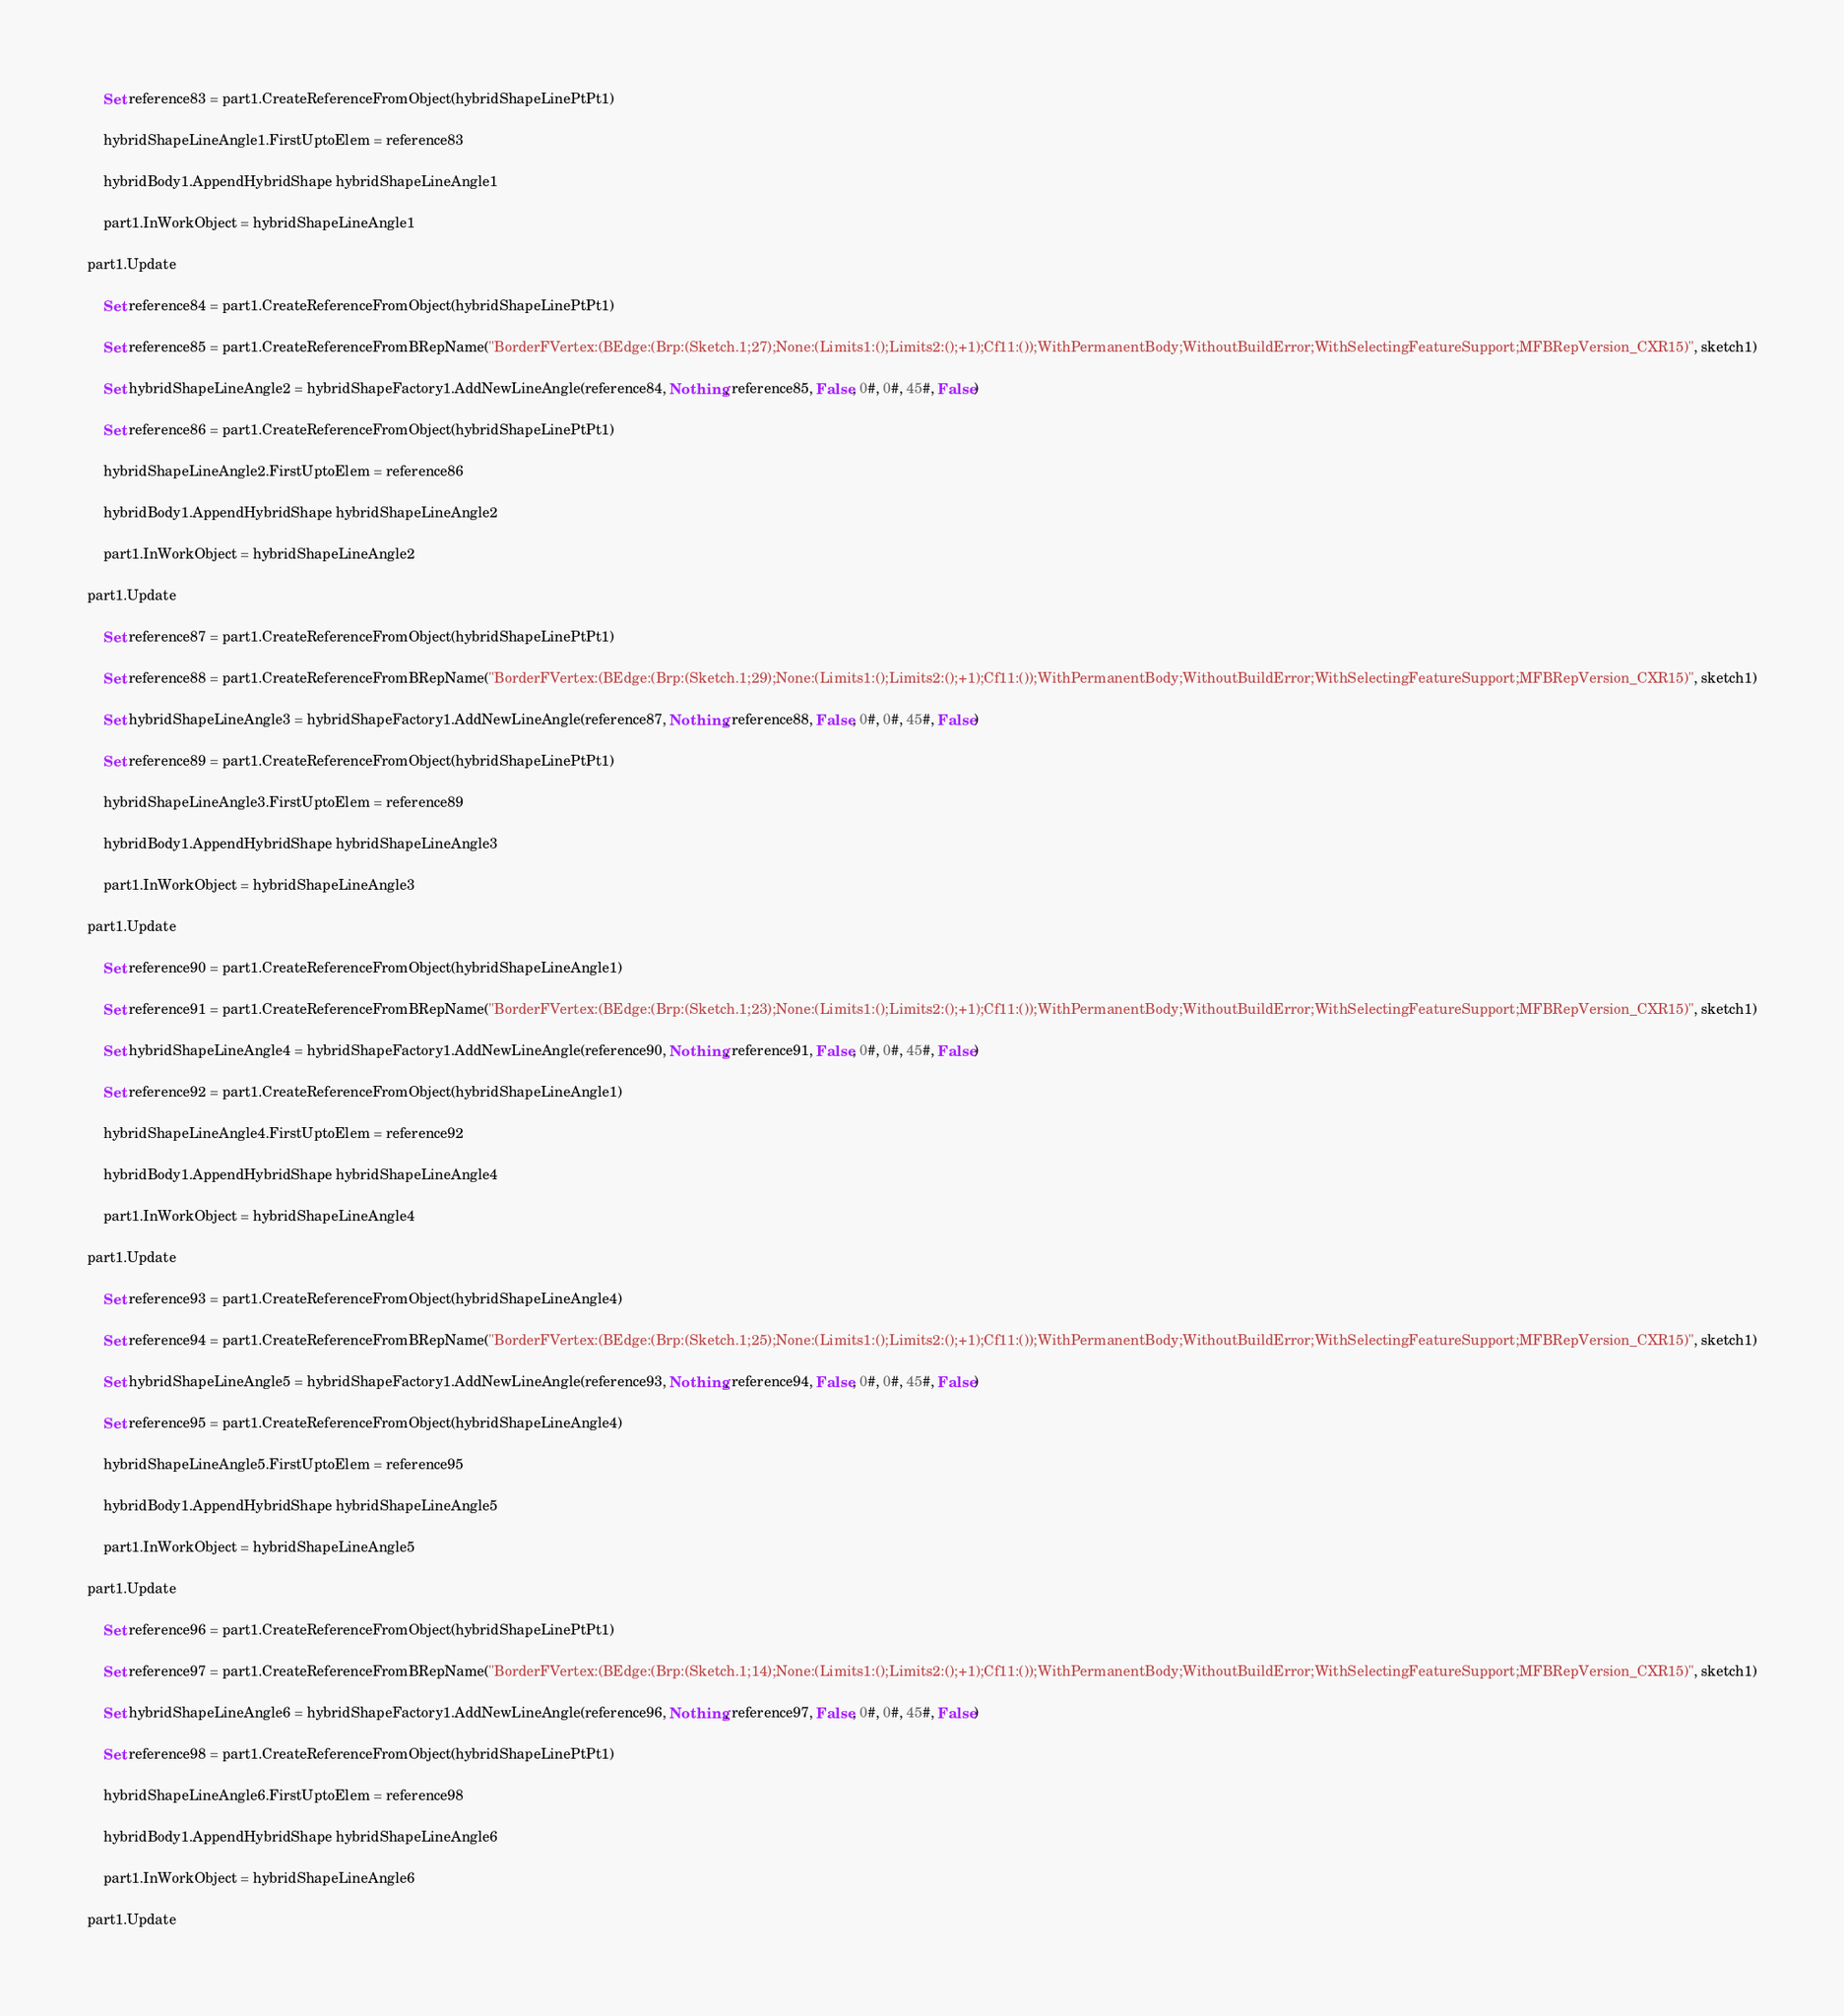Convert code to text. <code><loc_0><loc_0><loc_500><loc_500><_VisualBasic_>	Set reference83 = part1.CreateReferenceFromObject(hybridShapeLinePtPt1)

	hybridShapeLineAngle1.FirstUptoElem = reference83

	hybridBody1.AppendHybridShape hybridShapeLineAngle1

	part1.InWorkObject = hybridShapeLineAngle1

part1.Update

	Set reference84 = part1.CreateReferenceFromObject(hybridShapeLinePtPt1)

	Set reference85 = part1.CreateReferenceFromBRepName("BorderFVertex:(BEdge:(Brp:(Sketch.1;27);None:(Limits1:();Limits2:();+1);Cf11:());WithPermanentBody;WithoutBuildError;WithSelectingFeatureSupport;MFBRepVersion_CXR15)", sketch1)

	Set hybridShapeLineAngle2 = hybridShapeFactory1.AddNewLineAngle(reference84, Nothing, reference85, False, 0#, 0#, 45#, False)

	Set reference86 = part1.CreateReferenceFromObject(hybridShapeLinePtPt1)

	hybridShapeLineAngle2.FirstUptoElem = reference86

	hybridBody1.AppendHybridShape hybridShapeLineAngle2

	part1.InWorkObject = hybridShapeLineAngle2

part1.Update

	Set reference87 = part1.CreateReferenceFromObject(hybridShapeLinePtPt1)

	Set reference88 = part1.CreateReferenceFromBRepName("BorderFVertex:(BEdge:(Brp:(Sketch.1;29);None:(Limits1:();Limits2:();+1);Cf11:());WithPermanentBody;WithoutBuildError;WithSelectingFeatureSupport;MFBRepVersion_CXR15)", sketch1)

	Set hybridShapeLineAngle3 = hybridShapeFactory1.AddNewLineAngle(reference87, Nothing, reference88, False, 0#, 0#, 45#, False)

	Set reference89 = part1.CreateReferenceFromObject(hybridShapeLinePtPt1)

	hybridShapeLineAngle3.FirstUptoElem = reference89

	hybridBody1.AppendHybridShape hybridShapeLineAngle3

	part1.InWorkObject = hybridShapeLineAngle3

part1.Update

	Set reference90 = part1.CreateReferenceFromObject(hybridShapeLineAngle1)

	Set reference91 = part1.CreateReferenceFromBRepName("BorderFVertex:(BEdge:(Brp:(Sketch.1;23);None:(Limits1:();Limits2:();+1);Cf11:());WithPermanentBody;WithoutBuildError;WithSelectingFeatureSupport;MFBRepVersion_CXR15)", sketch1)

	Set hybridShapeLineAngle4 = hybridShapeFactory1.AddNewLineAngle(reference90, Nothing, reference91, False, 0#, 0#, 45#, False)

	Set reference92 = part1.CreateReferenceFromObject(hybridShapeLineAngle1)

	hybridShapeLineAngle4.FirstUptoElem = reference92

	hybridBody1.AppendHybridShape hybridShapeLineAngle4

	part1.InWorkObject = hybridShapeLineAngle4

part1.Update

	Set reference93 = part1.CreateReferenceFromObject(hybridShapeLineAngle4)

	Set reference94 = part1.CreateReferenceFromBRepName("BorderFVertex:(BEdge:(Brp:(Sketch.1;25);None:(Limits1:();Limits2:();+1);Cf11:());WithPermanentBody;WithoutBuildError;WithSelectingFeatureSupport;MFBRepVersion_CXR15)", sketch1)

	Set hybridShapeLineAngle5 = hybridShapeFactory1.AddNewLineAngle(reference93, Nothing, reference94, False, 0#, 0#, 45#, False)

	Set reference95 = part1.CreateReferenceFromObject(hybridShapeLineAngle4)

	hybridShapeLineAngle5.FirstUptoElem = reference95

	hybridBody1.AppendHybridShape hybridShapeLineAngle5

	part1.InWorkObject = hybridShapeLineAngle5

part1.Update

	Set reference96 = part1.CreateReferenceFromObject(hybridShapeLinePtPt1)

	Set reference97 = part1.CreateReferenceFromBRepName("BorderFVertex:(BEdge:(Brp:(Sketch.1;14);None:(Limits1:();Limits2:();+1);Cf11:());WithPermanentBody;WithoutBuildError;WithSelectingFeatureSupport;MFBRepVersion_CXR15)", sketch1)

	Set hybridShapeLineAngle6 = hybridShapeFactory1.AddNewLineAngle(reference96, Nothing, reference97, False, 0#, 0#, 45#, False)

	Set reference98 = part1.CreateReferenceFromObject(hybridShapeLinePtPt1)

	hybridShapeLineAngle6.FirstUptoElem = reference98

	hybridBody1.AppendHybridShape hybridShapeLineAngle6

	part1.InWorkObject = hybridShapeLineAngle6

part1.Update
</code> 